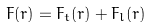Convert formula to latex. <formula><loc_0><loc_0><loc_500><loc_500>F ( r ) = F _ { t } ( r ) + F _ { l } ( r )</formula> 